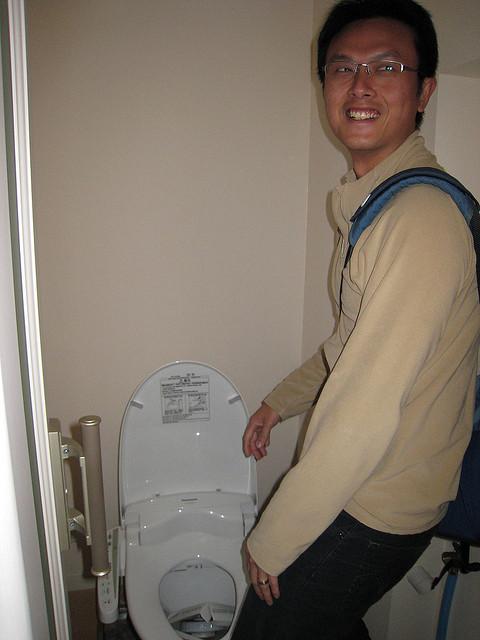How many rolls of toilet tissue do you see?
Give a very brief answer. 0. 